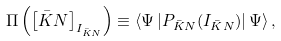<formula> <loc_0><loc_0><loc_500><loc_500>\Pi \left ( \left [ \bar { K } N \right ] _ { I _ { \bar { K } N } } \right ) \equiv \left \langle \Psi \left | P _ { \bar { K } N } ( I _ { \bar { K } N } ) \right | \Psi \right \rangle ,</formula> 